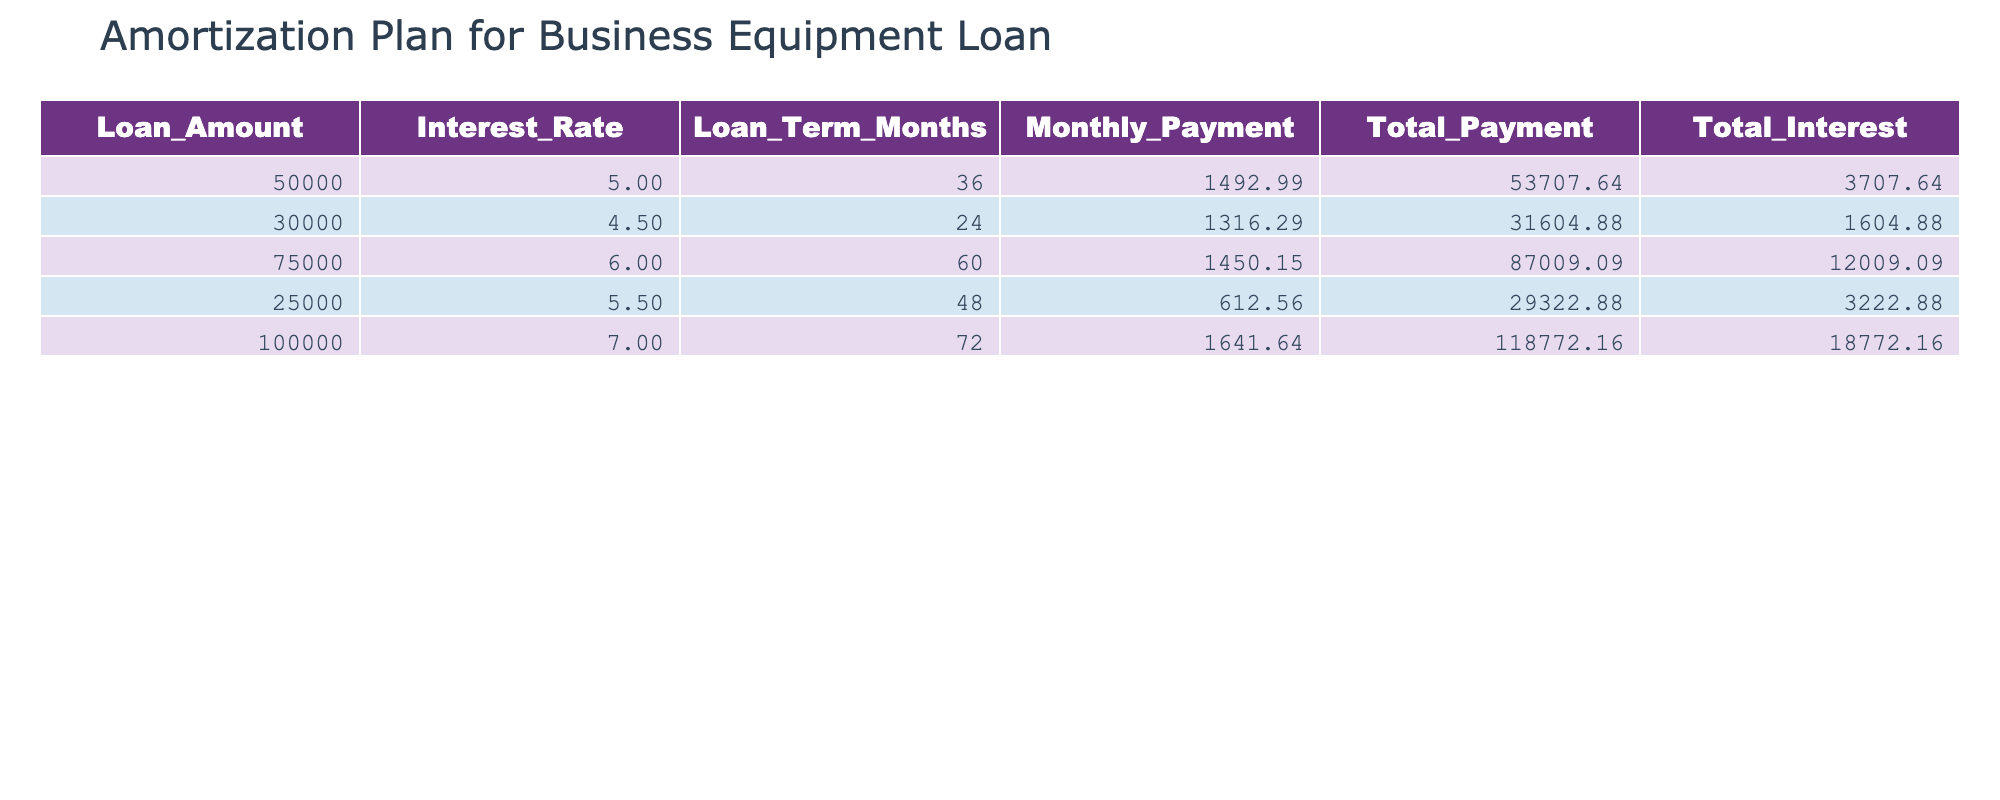What is the loan amount for the lowest monthly payment? Looking at the Monthly Payment column, the loan with the lowest monthly payment is 612.56, which corresponds to a loan amount of 25000.
Answer: 25000 What is the total payment for the loan with the highest interest rate? The loan with the highest interest rate is 7% with a total payment of 118772.16.
Answer: 118772.16 What is the total interest paid for the $75000 loan? Referring to the Total Interest column for the $75000 loan, it shows a total interest of 12009.09.
Answer: 12009.09 Is the monthly payment for a $30000 loan higher than for a $25000 loan? The monthly payment for the $30000 loan is 1316.29, while the payment for the $25000 loan is 612.56. Since 1316.29 is greater than 612.56, the statement is true.
Answer: Yes What is the total payment for all loans combined? Summing up the Total Payment column gives 53707.64 + 31604.88 + 87009.09 + 29322.88 + 118772.16 = 335416.65.
Answer: 335416.65 What is the average total interest paid across all loans? To find the average, sum the total interest (3707.64 + 1604.88 + 12009.09 + 3222.88 + 18772.16 = 40016.65) and divide by the number of loans (5): 40016.65 / 5 = 8003.33.
Answer: 8003.33 Is there a loan amount that has a monthly payment of over 1500? The monthly payments indicate that both the $50000 loan (1492.99) and the $75000 loan (1450.15) are below 1500. Therefore, there are no loans with payments over 1500.
Answer: No Which loan has the longest term? The longest loan term is 72 months, corresponding to the $100000 loan.
Answer: 100000 What is the difference in total payments between the lowest and highest loan amounts? The lowest total payment is for the $25000 loan at 29322.88, and the highest is for the $100000 loan at 118772.16. The difference is 118772.16 - 29322.88 = 89449.28.
Answer: 89449.28 